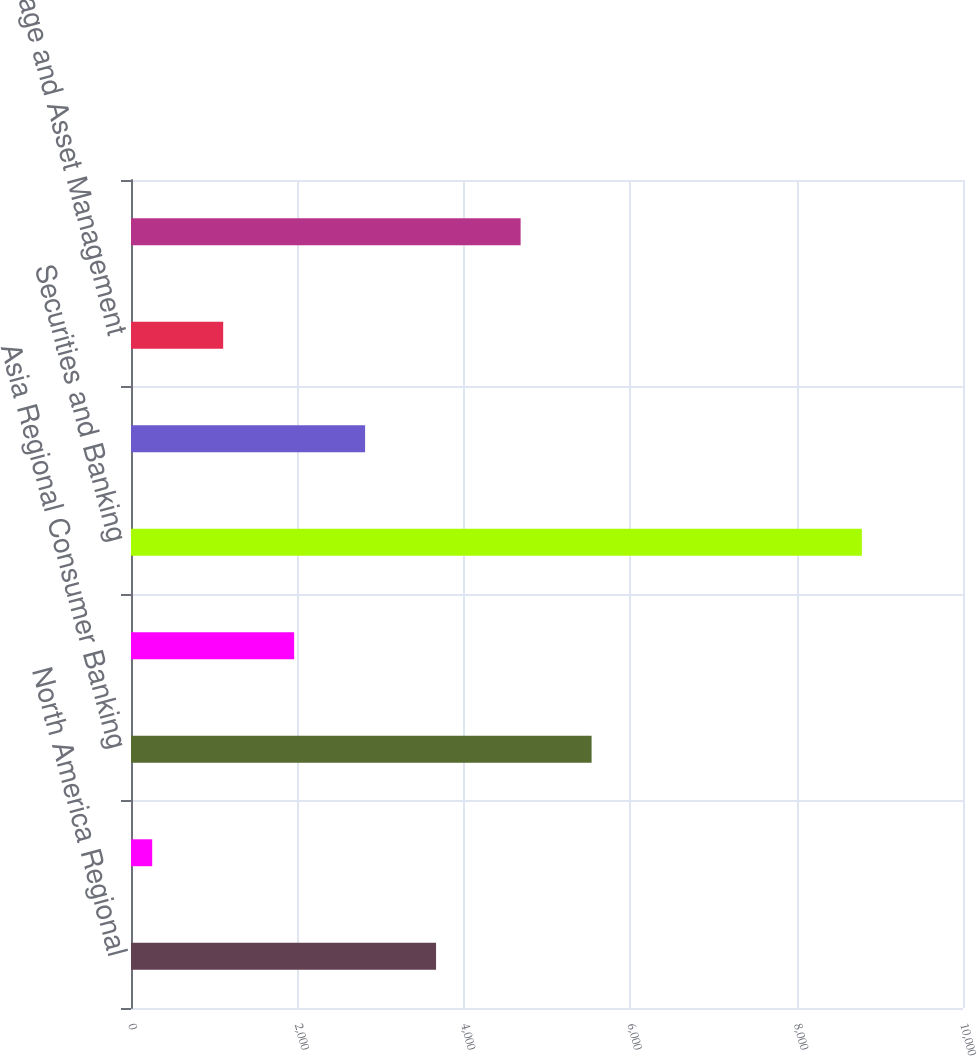Convert chart to OTSL. <chart><loc_0><loc_0><loc_500><loc_500><bar_chart><fcel>North America Regional<fcel>EMEA Regional Consumer Banking<fcel>Asia Regional Consumer Banking<fcel>Latin America Regional<fcel>Securities and Banking<fcel>Transaction Services<fcel>Brokerage and Asset Management<fcel>Local Consumer Lending -Cards<nl><fcel>3666.6<fcel>255<fcel>5535.9<fcel>1960.8<fcel>8784<fcel>2813.7<fcel>1107.9<fcel>4683<nl></chart> 